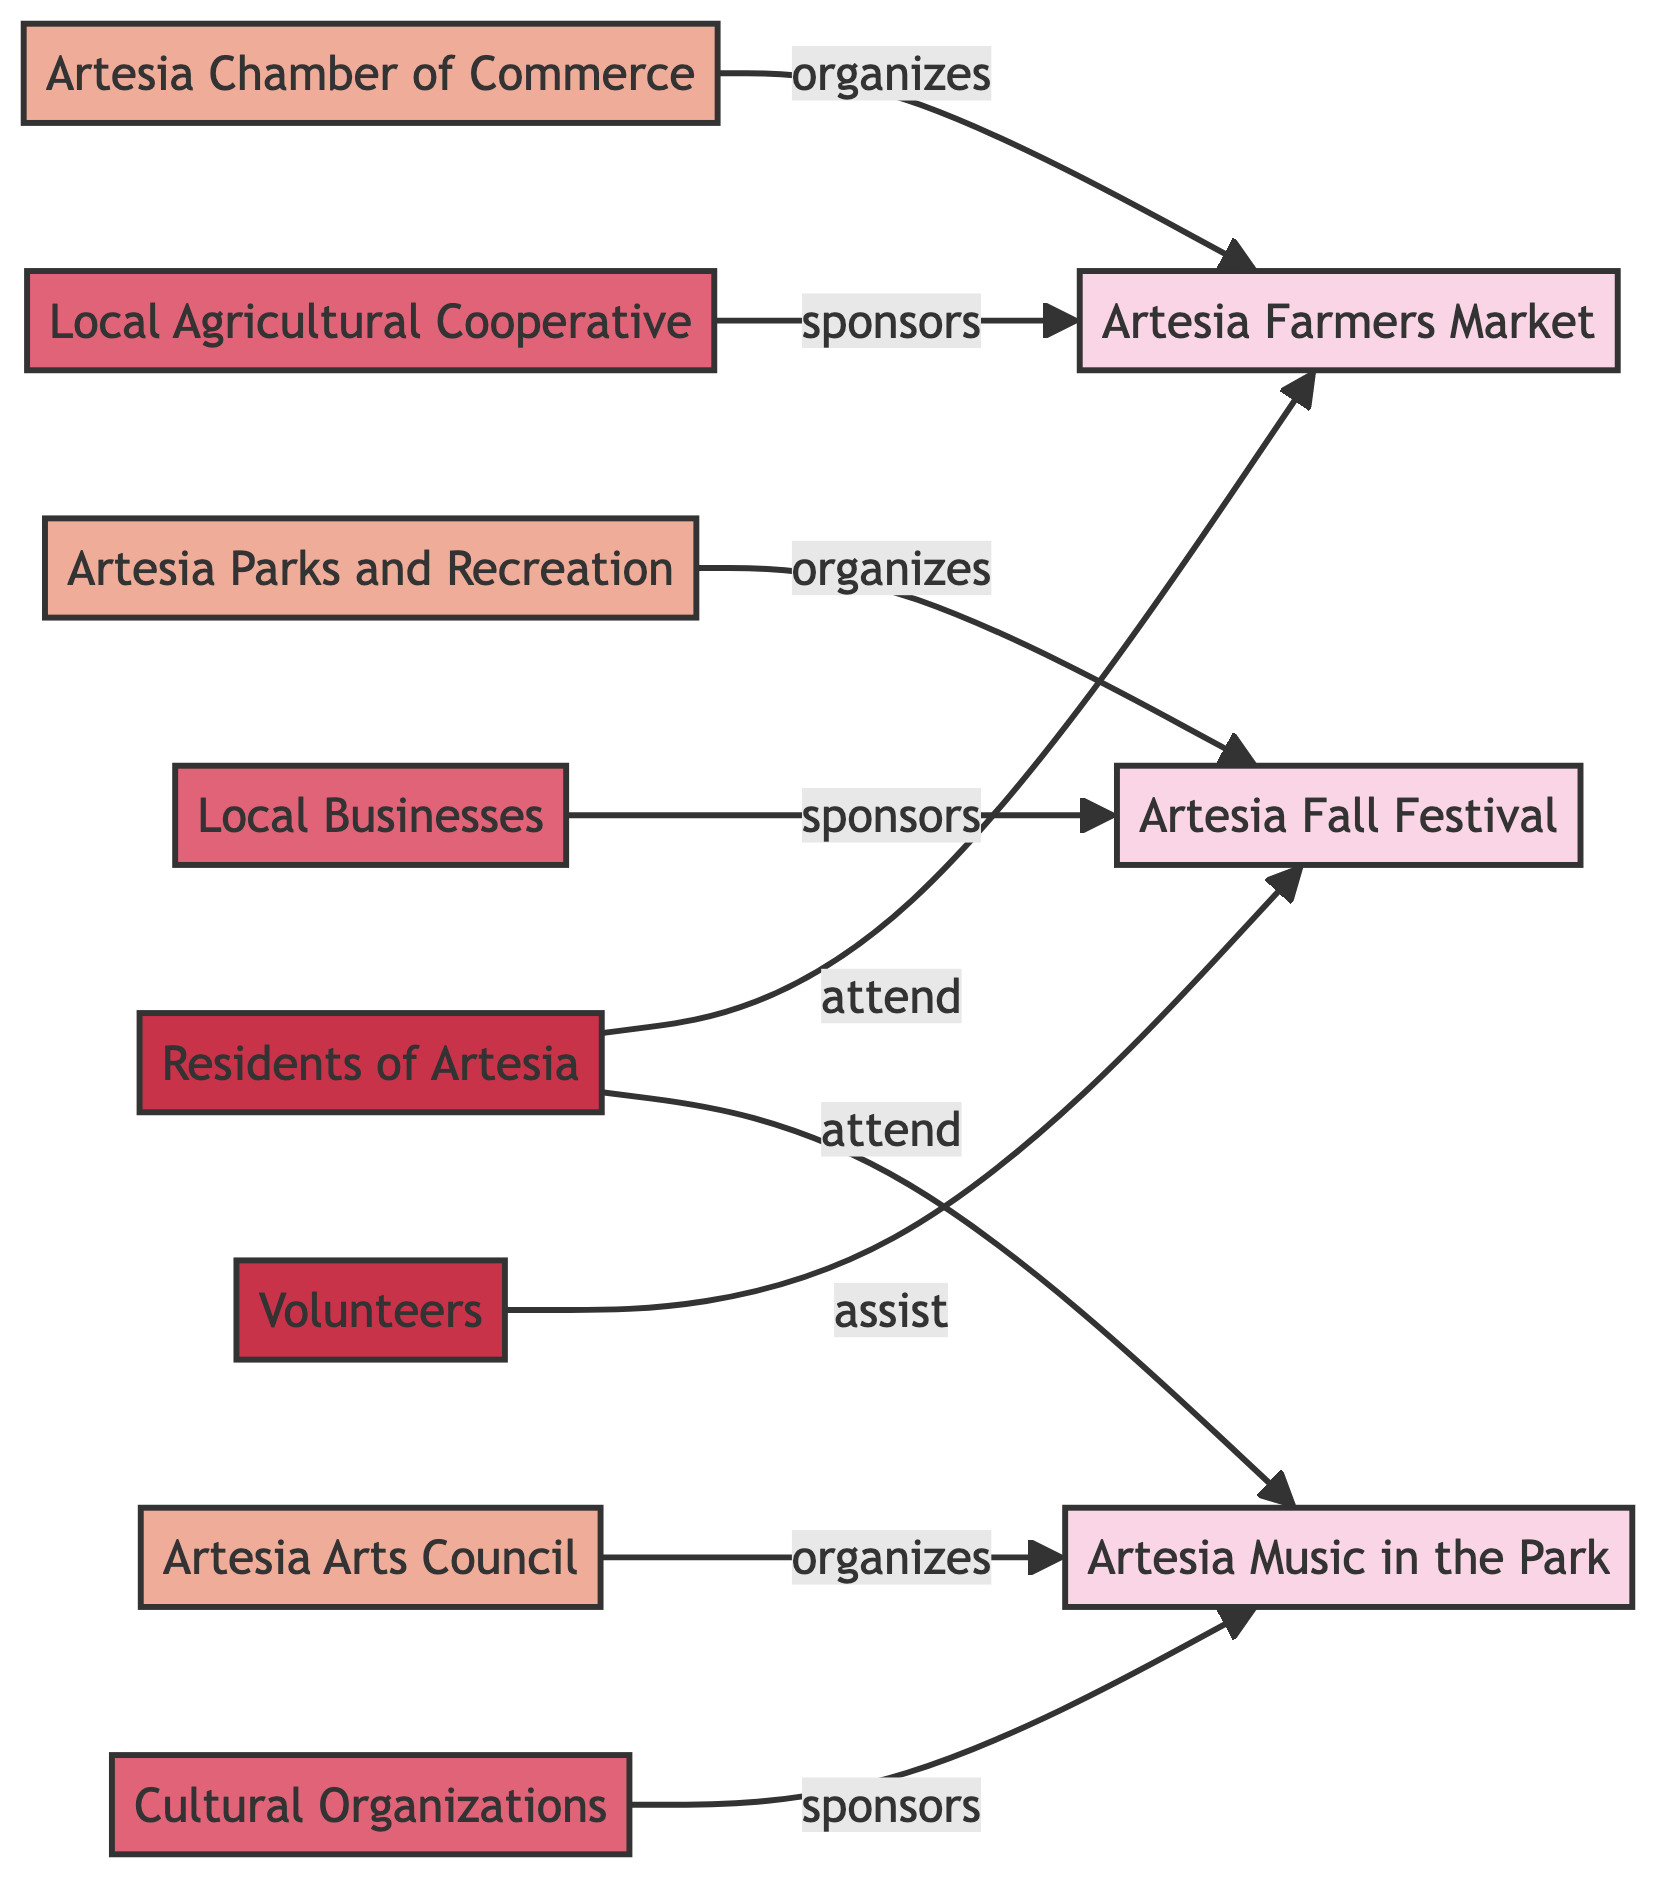What's the total number of events in the diagram? By inspecting the nodes in the diagram, I can identify three events: Artesia Farmers Market, Artesia Fall Festival, and Artesia Music in the Park. Therefore, the total count of events is 3.
Answer: 3 Who organizes the Artesia Farmers Market? The diagram shows an arrow pointing from the Artesia Chamber of Commerce to the Artesia Farmers Market with the label "organizes." This indicates that the Artesia Chamber of Commerce is the organizer of the event.
Answer: Artesia Chamber of Commerce How many sponsors are there for the Artesia Fall Festival? The diagram includes one node labeled Local Businesses pointing to the Artesia Fall Festival with "sponsors" as the relationship. Thus, there is 1 sponsor for the Artesia Fall Festival.
Answer: 1 Which participants attend the Artesia Music in the Park event? The diagram indicates that there is an arrow from Residents of Artesia to Artesia Music in the Park with the relationship "attend." Thus, the participants who attend are the Residents of Artesia.
Answer: Residents of Artesia What type of event is organized by the Artesia Arts Council? The diagram shows the Artesia Arts Council organizing the Artesia Music in the Park event. Since Artesia Music in the Park is categorized as an Event, the type is Event.
Answer: Event Who assists at the Artesia Fall Festival? There is a line that shows Volunteers pointing to the Artesia Fall Festival with the label "assist." This indicates that Volunteers are the ones who assist at this event.
Answer: Volunteers What is the relationship between Local Agricultural Cooperative and Artesia Farmers Market? The diagram illustrates a direct link from the Local Agricultural Cooperative to the Artesia Farmers Market marked with "sponsors," indicating that the relationship is one of sponsorship.
Answer: sponsors How many unique organizers are involved in these events? By examining the organizing nodes in the diagram, I find three distinct organizers: Artesia Chamber of Commerce, Artesia Parks and Recreation, and Artesia Arts Council. Therefore, the total number of unique organizers is 3.
Answer: 3 What is the relationship between Cultural Organizations and Artesia Music in the Park? There is an arrow from Cultural Organizations to Artesia Music in the Park marked with "sponsors." This relationship indicates that Cultural Organizations sponsor the Artesia Music in the Park event.
Answer: sponsors 